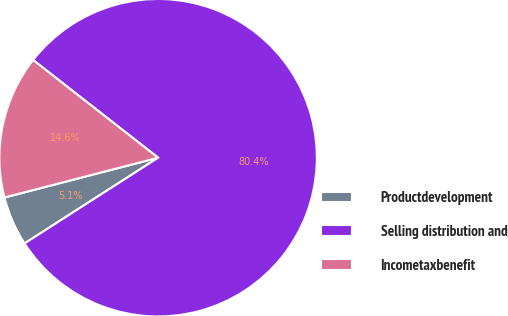Convert chart to OTSL. <chart><loc_0><loc_0><loc_500><loc_500><pie_chart><fcel>Productdevelopment<fcel>Selling distribution and<fcel>Incometaxbenefit<nl><fcel>5.05%<fcel>80.36%<fcel>14.59%<nl></chart> 